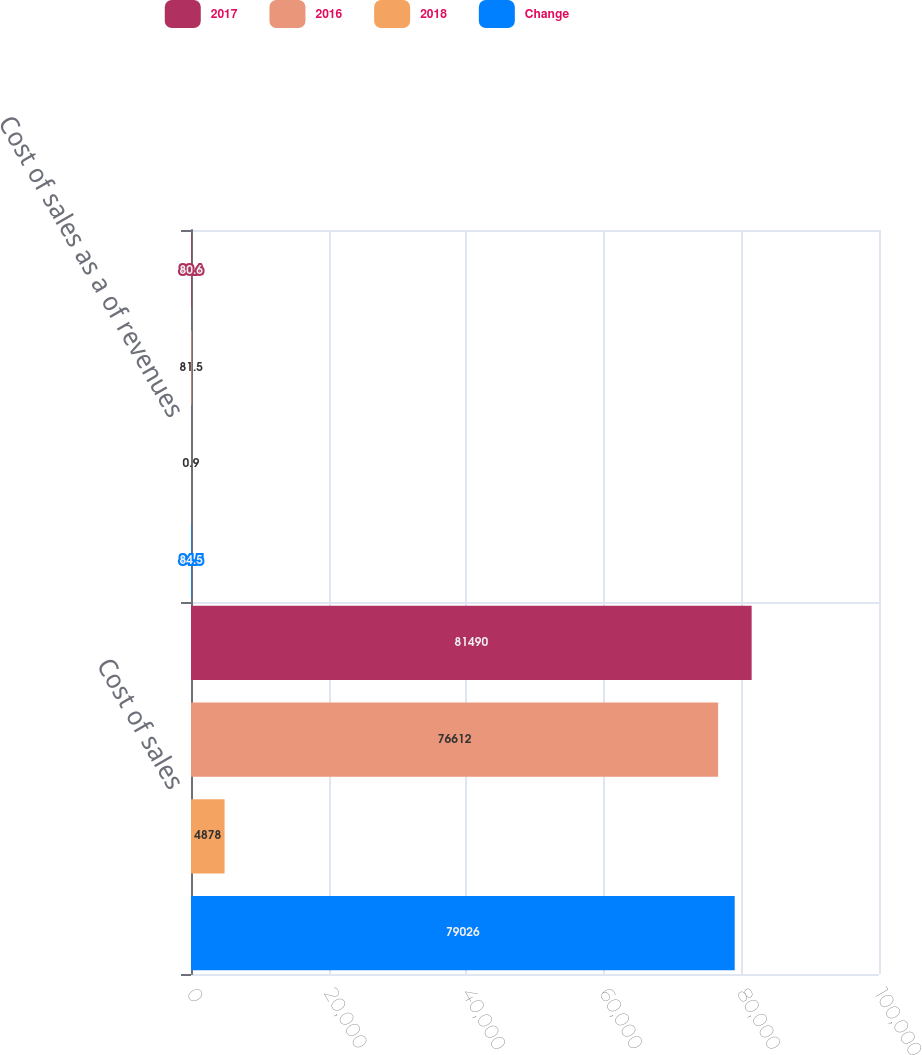Convert chart to OTSL. <chart><loc_0><loc_0><loc_500><loc_500><stacked_bar_chart><ecel><fcel>Cost of sales<fcel>Cost of sales as a of revenues<nl><fcel>2017<fcel>81490<fcel>80.6<nl><fcel>2016<fcel>76612<fcel>81.5<nl><fcel>2018<fcel>4878<fcel>0.9<nl><fcel>Change<fcel>79026<fcel>84.5<nl></chart> 